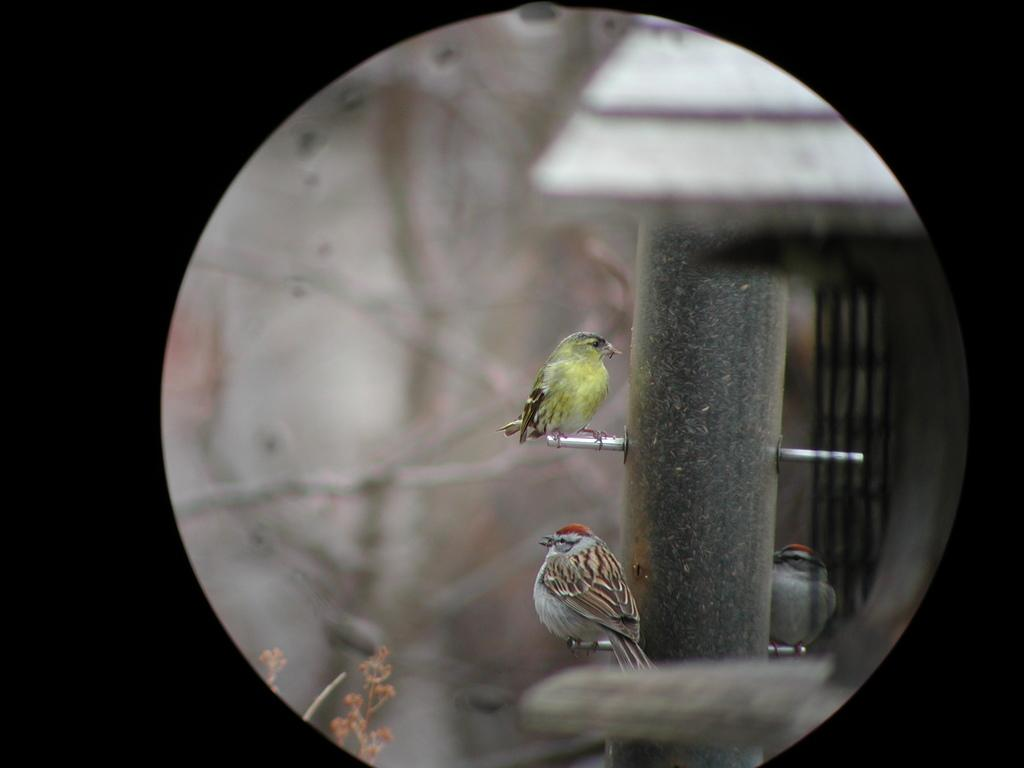What type of animals can be seen in the image? There are birds in the image. Where are the birds located in the image? The birds are standing on a pole. Is there anything else on the pole besides the birds? Yes, there is a thing present on the pole. What type of grass can be seen growing around the pole in the image? There is no grass visible in the image; it only features birds standing on a pole with an unspecified object. 